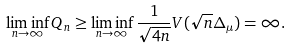Convert formula to latex. <formula><loc_0><loc_0><loc_500><loc_500>\liminf _ { n \to \infty } Q _ { n } \geq \liminf _ { n \to \infty } \frac { 1 } { \sqrt { 4 n } } V ( \sqrt { n } \Delta _ { \mu } ) = \infty .</formula> 